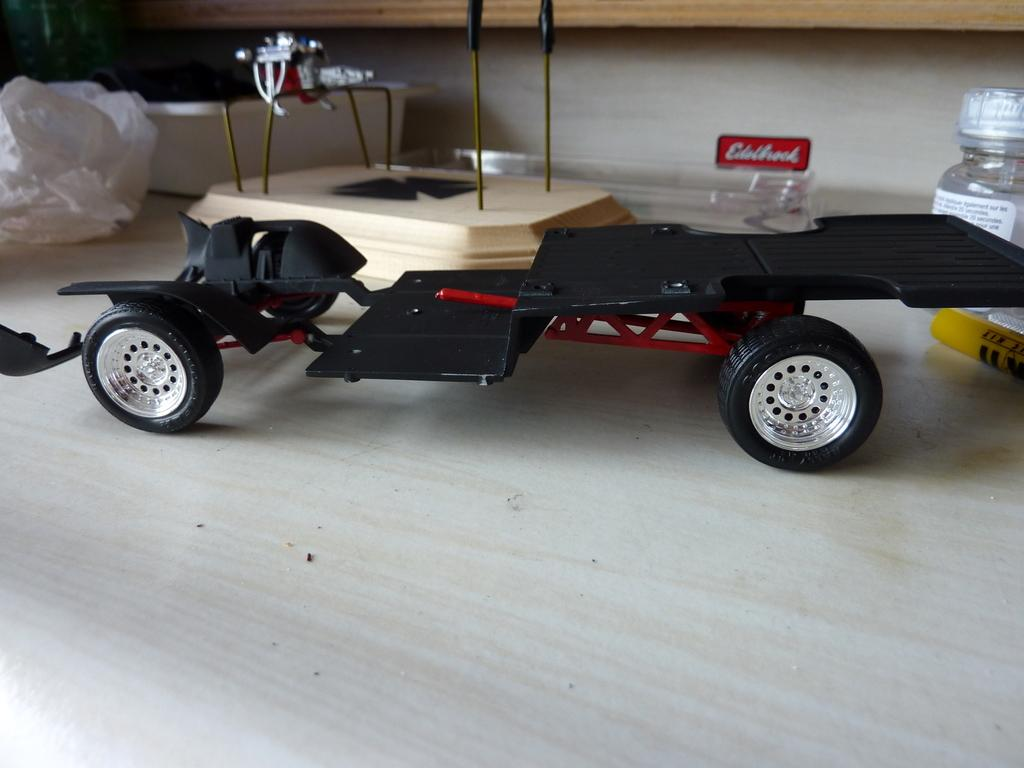What type of toy is in the image? There is a black toy in the image. What is the small container made of in the image? There is a small glass bottle in the image. What type of bag is in the image? There is a polythene bag in the image. What material is the object made of in the image? There is a wooden object in the image. How many rabbits are in the image? There are no rabbits present in the image. What color is your mom's hair in the image? There is no person, including your mom, present in the image. 